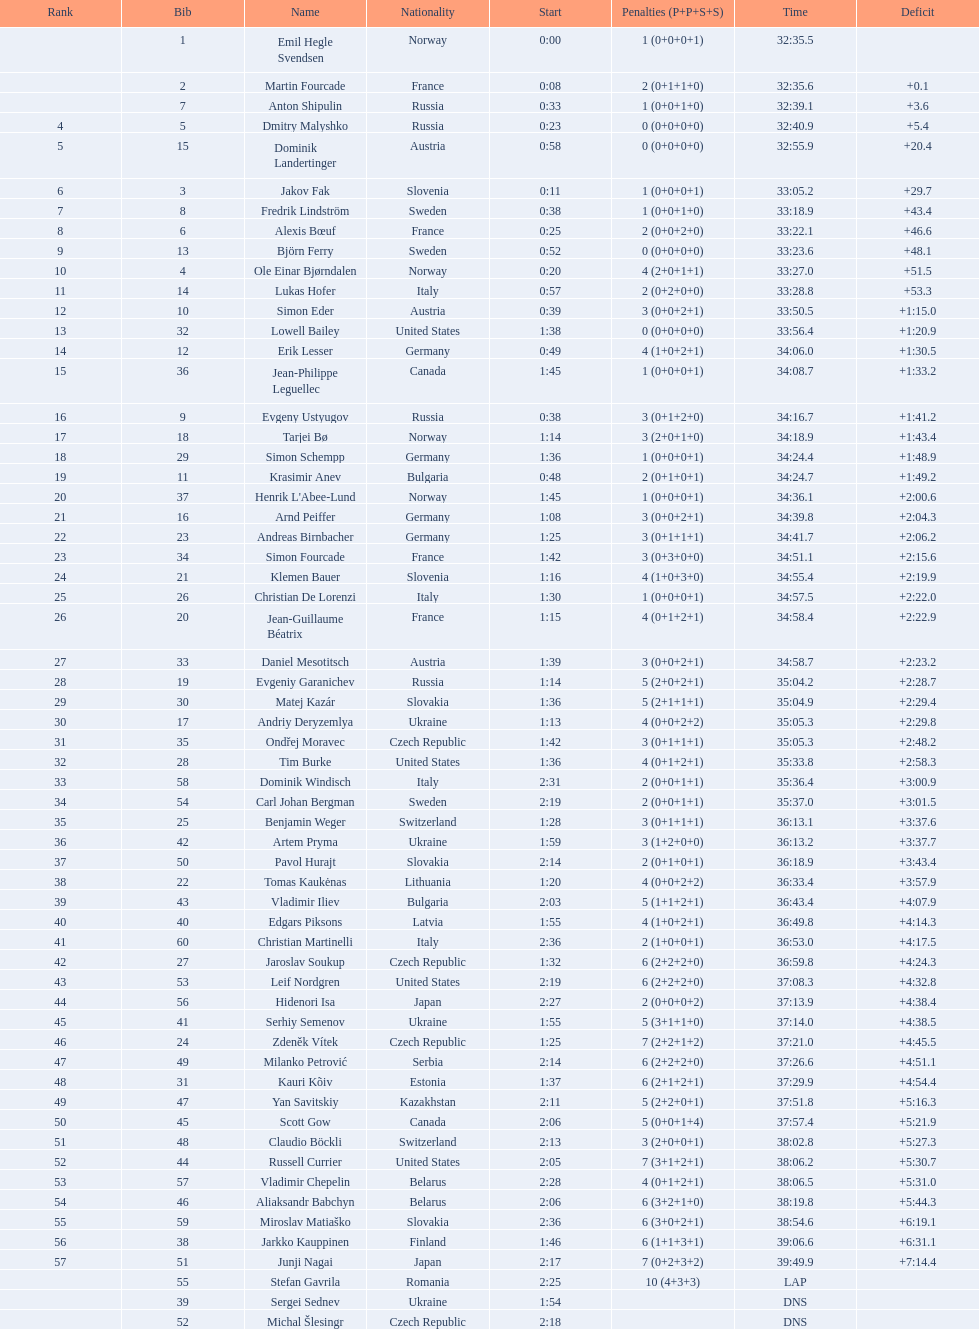How many took at least 35:00 to finish? 30. 